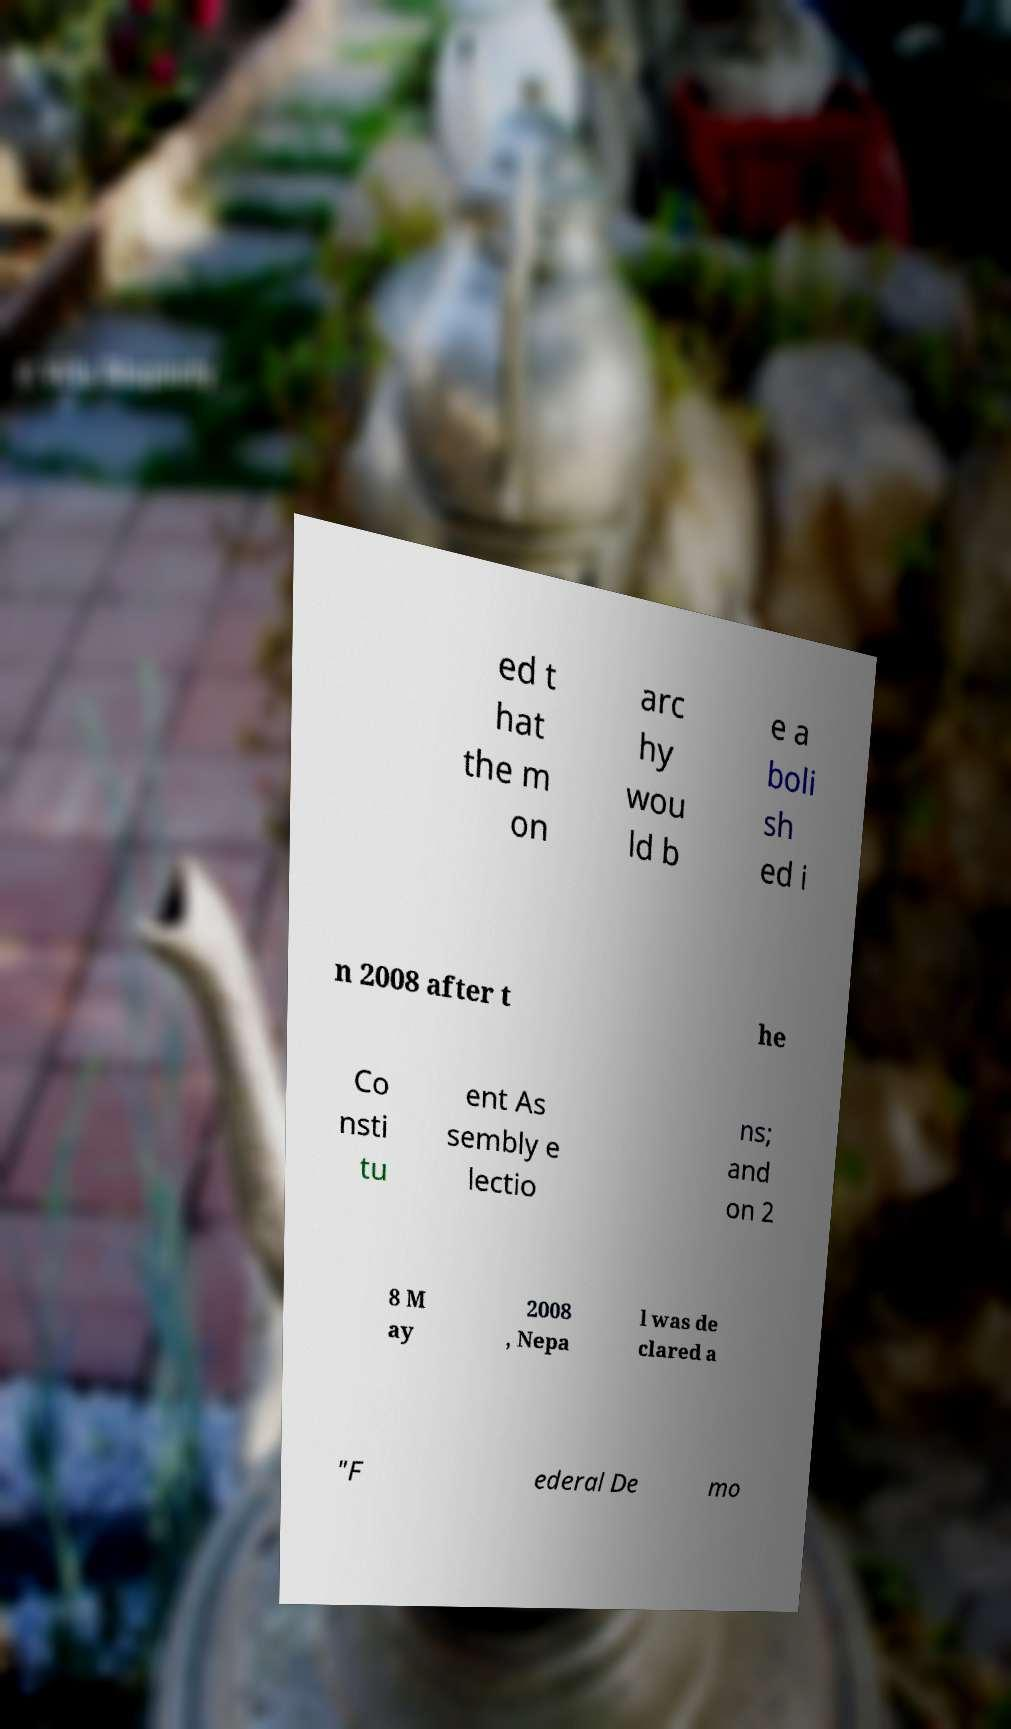For documentation purposes, I need the text within this image transcribed. Could you provide that? ed t hat the m on arc hy wou ld b e a boli sh ed i n 2008 after t he Co nsti tu ent As sembly e lectio ns; and on 2 8 M ay 2008 , Nepa l was de clared a "F ederal De mo 